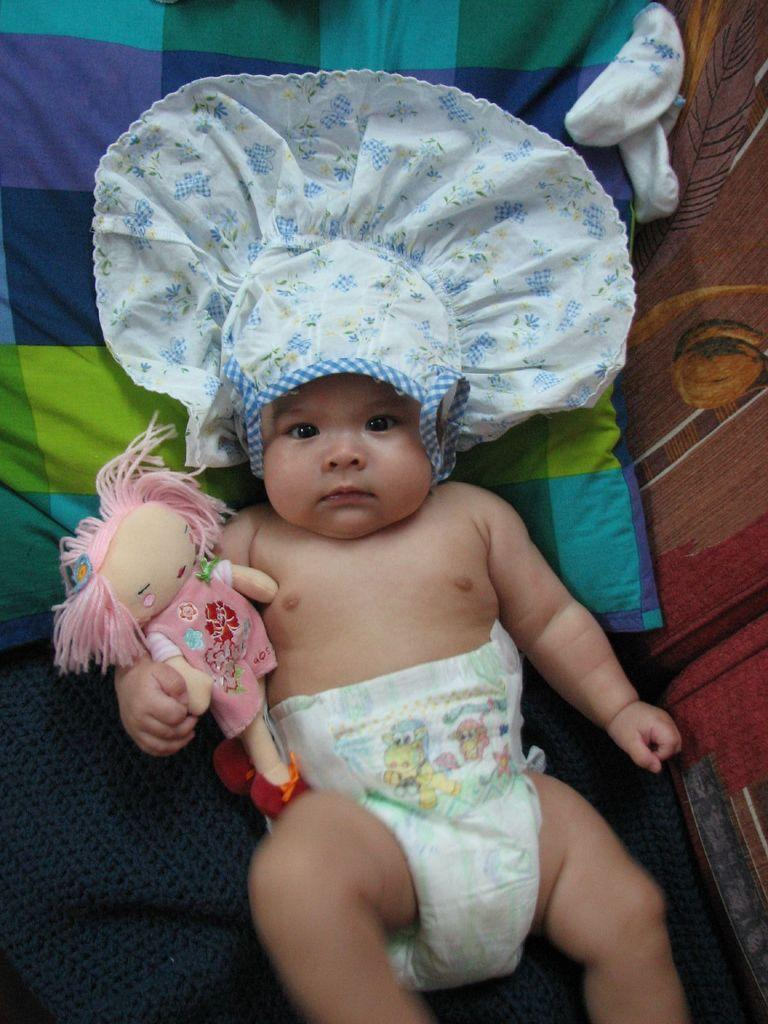What is the main subject of the image? There is a baby in the image. What can be seen behind the baby? There is a doll behind the baby. What is on the bed in the image? There is a pillow on the bed in the image. What type of coast can be seen in the image? There is no coast visible in the image; it features a baby, a doll, and a pillow on a bed. How does the zephyr affect the baby in the image? There is no mention of a zephyr or any wind in the image, so its effect on the baby cannot be determined. 